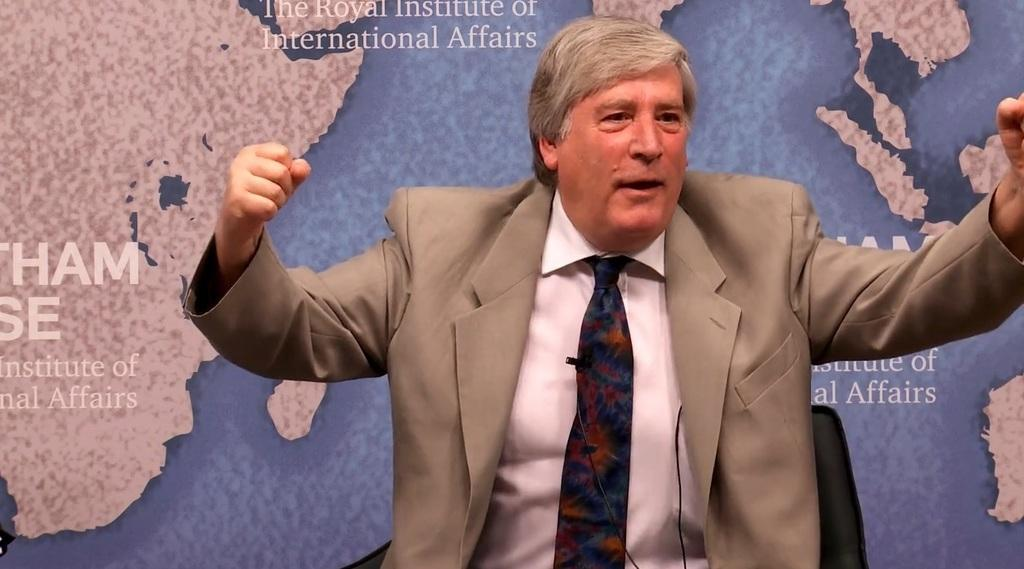Who is present in the image? There is a man in the image. What is the man doing in the image? The man is seated on a chair. What is the man wearing in the image? The man is wearing a coat and a tie. What additional detail can be observed on the man's clothing? There is a map visible on the back of the man. What type of salt is being used to season the man's food in the image? There is no food or salt present in the image; it only features a man seated on a chair with a map on his back. 